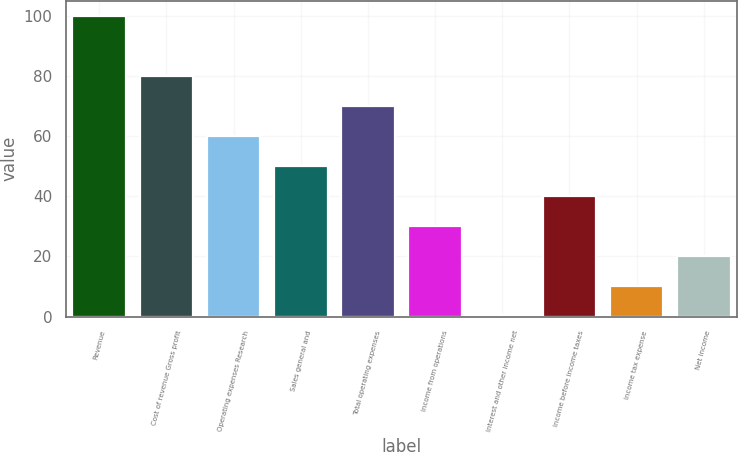Convert chart to OTSL. <chart><loc_0><loc_0><loc_500><loc_500><bar_chart><fcel>Revenue<fcel>Cost of revenue Gross profit<fcel>Operating expenses Research<fcel>Sales general and<fcel>Total operating expenses<fcel>Income from operations<fcel>Interest and other income net<fcel>Income before income taxes<fcel>Income tax expense<fcel>Net income<nl><fcel>100<fcel>80.08<fcel>60.16<fcel>50.2<fcel>70.12<fcel>30.28<fcel>0.4<fcel>40.24<fcel>10.36<fcel>20.32<nl></chart> 